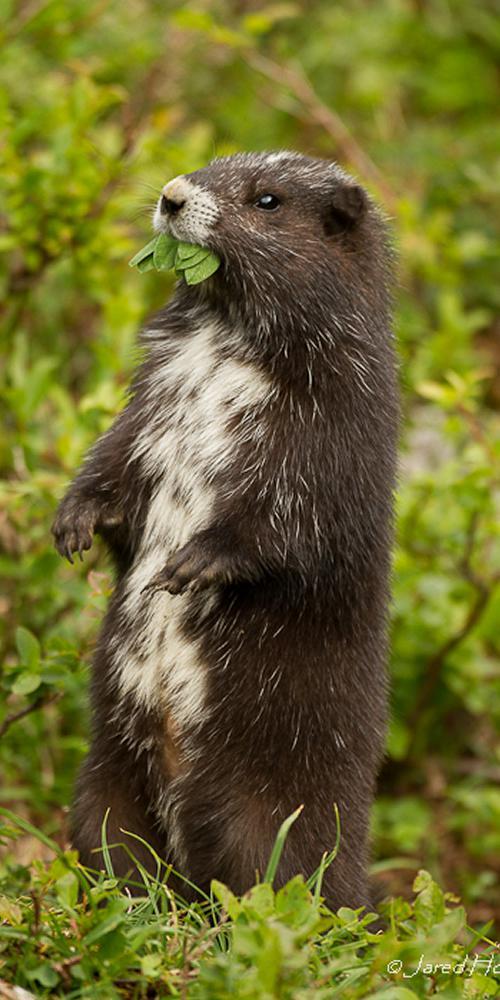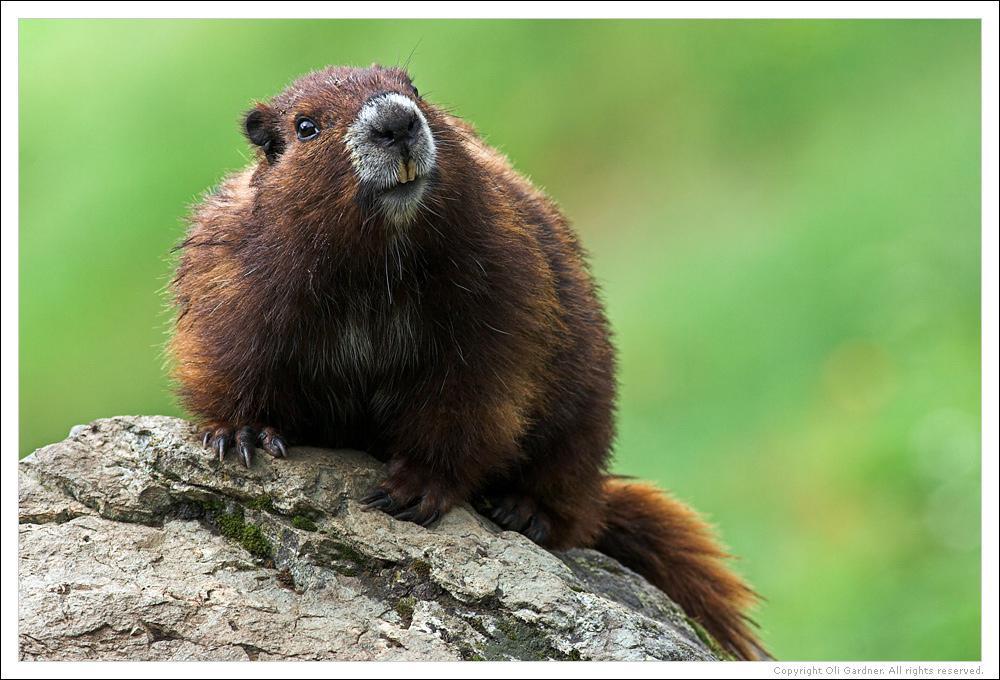The first image is the image on the left, the second image is the image on the right. Considering the images on both sides, is "One of the gophers has a long white underbelly and the gopher that is sitting on a rock or mossy log, does not." valid? Answer yes or no. Yes. The first image is the image on the left, the second image is the image on the right. For the images displayed, is the sentence "the animal is standing up on the left pic" factually correct? Answer yes or no. Yes. 